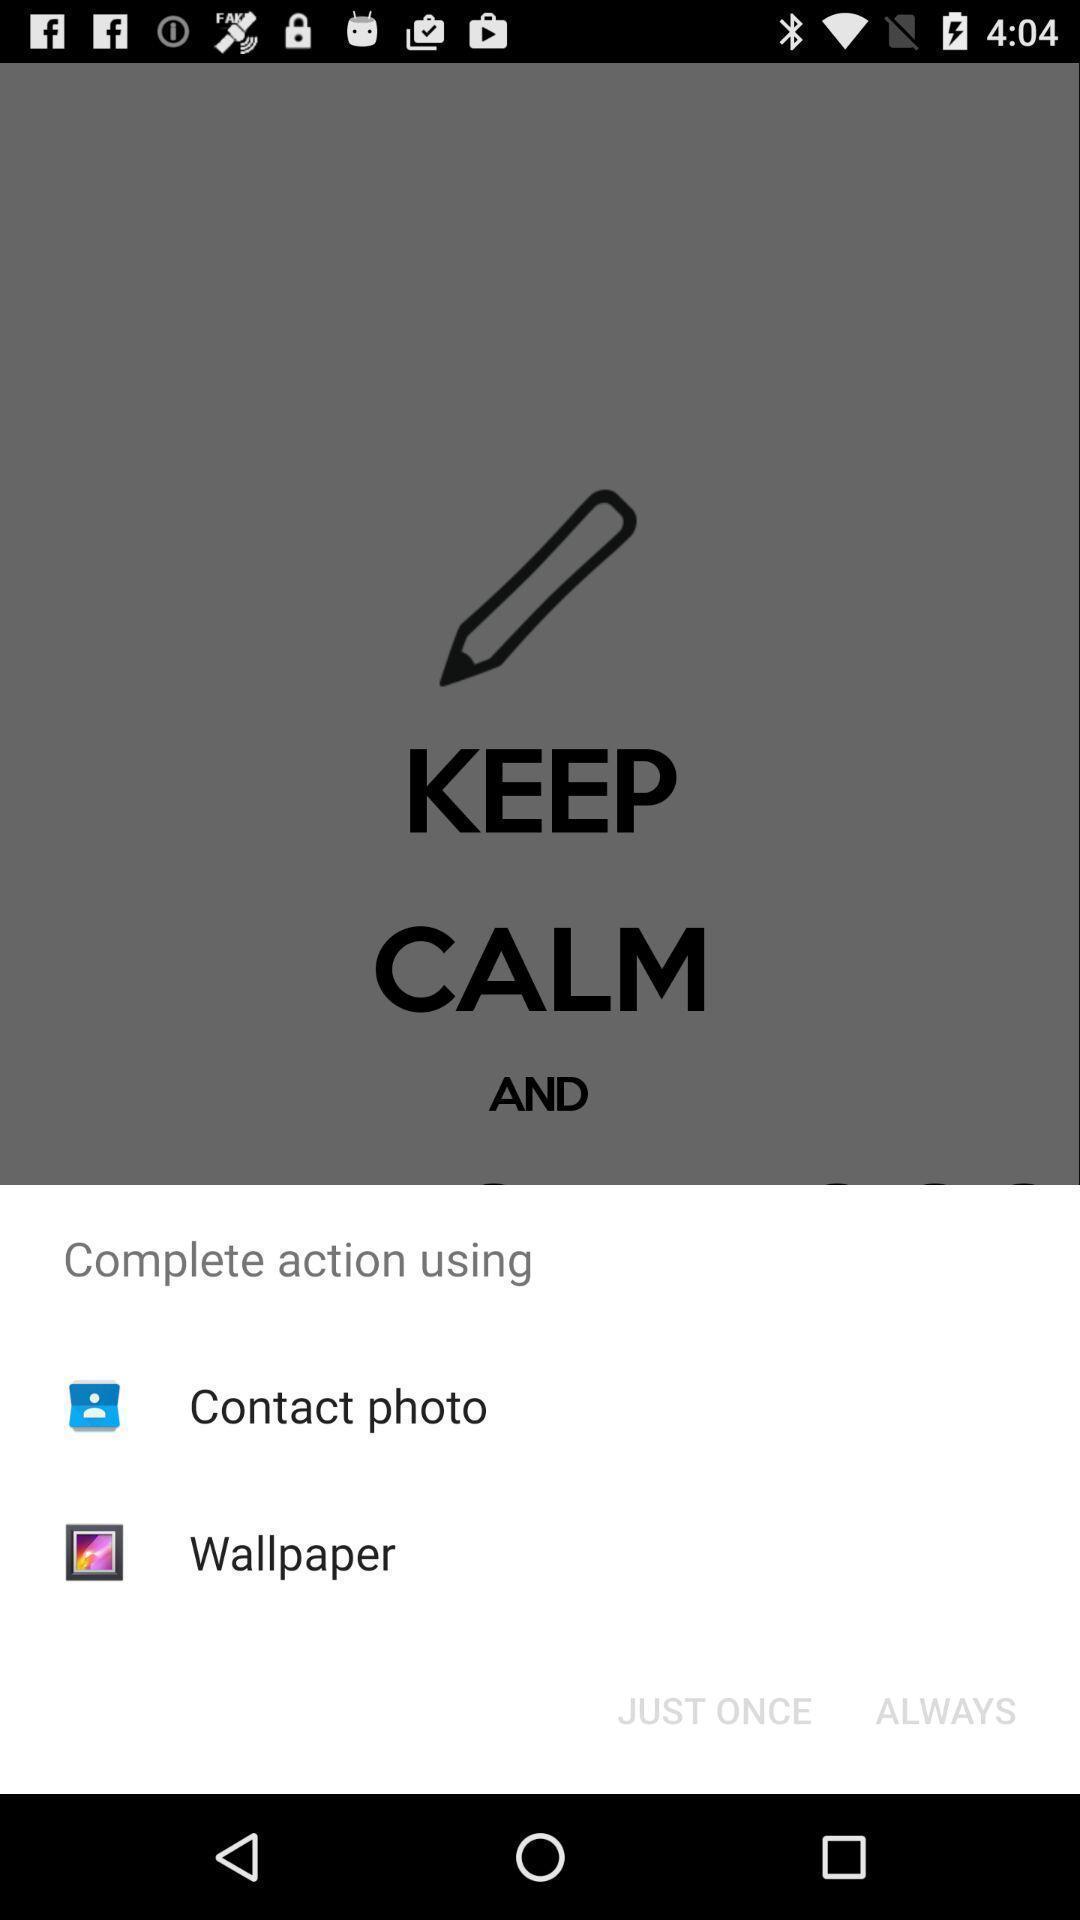Tell me about the visual elements in this screen capture. Pop-up showing options to complete the action. 